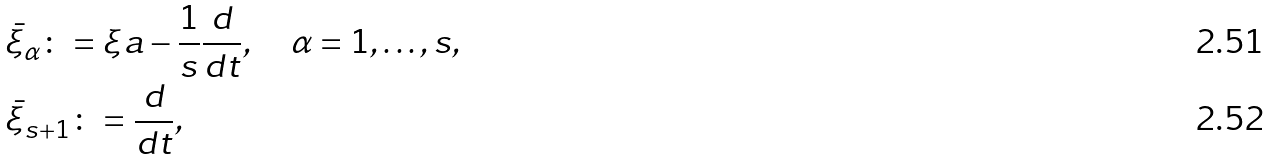Convert formula to latex. <formula><loc_0><loc_0><loc_500><loc_500>& \bar { \xi } _ { \alpha } \colon = \xi a - \frac { 1 } { s } \frac { d } { d t } , \quad \alpha = 1 , \dots , s , \\ & \bar { \xi } _ { s + 1 } \colon = \frac { d } { d t } ,</formula> 